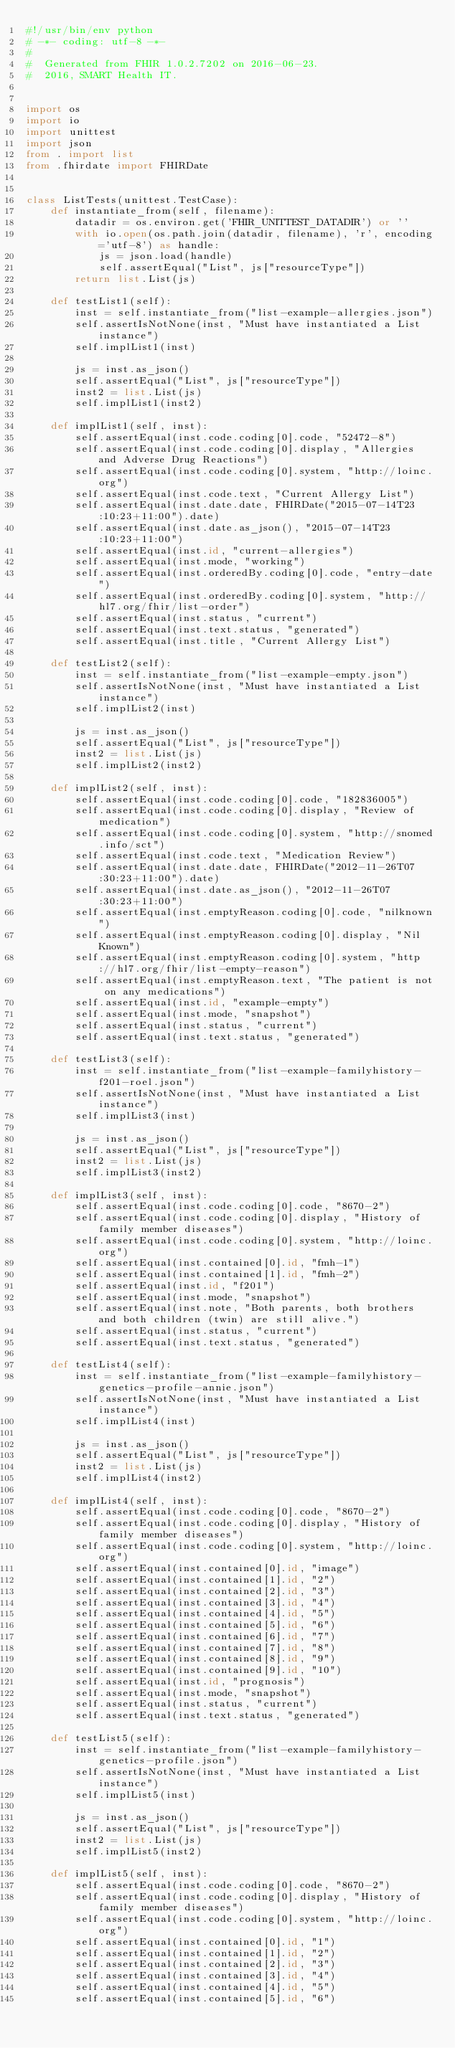<code> <loc_0><loc_0><loc_500><loc_500><_Python_>#!/usr/bin/env python
# -*- coding: utf-8 -*-
#
#  Generated from FHIR 1.0.2.7202 on 2016-06-23.
#  2016, SMART Health IT.


import os
import io
import unittest
import json
from . import list
from .fhirdate import FHIRDate


class ListTests(unittest.TestCase):
    def instantiate_from(self, filename):
        datadir = os.environ.get('FHIR_UNITTEST_DATADIR') or ''
        with io.open(os.path.join(datadir, filename), 'r', encoding='utf-8') as handle:
            js = json.load(handle)
            self.assertEqual("List", js["resourceType"])
        return list.List(js)
    
    def testList1(self):
        inst = self.instantiate_from("list-example-allergies.json")
        self.assertIsNotNone(inst, "Must have instantiated a List instance")
        self.implList1(inst)
        
        js = inst.as_json()
        self.assertEqual("List", js["resourceType"])
        inst2 = list.List(js)
        self.implList1(inst2)
    
    def implList1(self, inst):
        self.assertEqual(inst.code.coding[0].code, "52472-8")
        self.assertEqual(inst.code.coding[0].display, "Allergies and Adverse Drug Reactions")
        self.assertEqual(inst.code.coding[0].system, "http://loinc.org")
        self.assertEqual(inst.code.text, "Current Allergy List")
        self.assertEqual(inst.date.date, FHIRDate("2015-07-14T23:10:23+11:00").date)
        self.assertEqual(inst.date.as_json(), "2015-07-14T23:10:23+11:00")
        self.assertEqual(inst.id, "current-allergies")
        self.assertEqual(inst.mode, "working")
        self.assertEqual(inst.orderedBy.coding[0].code, "entry-date")
        self.assertEqual(inst.orderedBy.coding[0].system, "http://hl7.org/fhir/list-order")
        self.assertEqual(inst.status, "current")
        self.assertEqual(inst.text.status, "generated")
        self.assertEqual(inst.title, "Current Allergy List")
    
    def testList2(self):
        inst = self.instantiate_from("list-example-empty.json")
        self.assertIsNotNone(inst, "Must have instantiated a List instance")
        self.implList2(inst)
        
        js = inst.as_json()
        self.assertEqual("List", js["resourceType"])
        inst2 = list.List(js)
        self.implList2(inst2)
    
    def implList2(self, inst):
        self.assertEqual(inst.code.coding[0].code, "182836005")
        self.assertEqual(inst.code.coding[0].display, "Review of medication")
        self.assertEqual(inst.code.coding[0].system, "http://snomed.info/sct")
        self.assertEqual(inst.code.text, "Medication Review")
        self.assertEqual(inst.date.date, FHIRDate("2012-11-26T07:30:23+11:00").date)
        self.assertEqual(inst.date.as_json(), "2012-11-26T07:30:23+11:00")
        self.assertEqual(inst.emptyReason.coding[0].code, "nilknown")
        self.assertEqual(inst.emptyReason.coding[0].display, "Nil Known")
        self.assertEqual(inst.emptyReason.coding[0].system, "http://hl7.org/fhir/list-empty-reason")
        self.assertEqual(inst.emptyReason.text, "The patient is not on any medications")
        self.assertEqual(inst.id, "example-empty")
        self.assertEqual(inst.mode, "snapshot")
        self.assertEqual(inst.status, "current")
        self.assertEqual(inst.text.status, "generated")
    
    def testList3(self):
        inst = self.instantiate_from("list-example-familyhistory-f201-roel.json")
        self.assertIsNotNone(inst, "Must have instantiated a List instance")
        self.implList3(inst)
        
        js = inst.as_json()
        self.assertEqual("List", js["resourceType"])
        inst2 = list.List(js)
        self.implList3(inst2)
    
    def implList3(self, inst):
        self.assertEqual(inst.code.coding[0].code, "8670-2")
        self.assertEqual(inst.code.coding[0].display, "History of family member diseases")
        self.assertEqual(inst.code.coding[0].system, "http://loinc.org")
        self.assertEqual(inst.contained[0].id, "fmh-1")
        self.assertEqual(inst.contained[1].id, "fmh-2")
        self.assertEqual(inst.id, "f201")
        self.assertEqual(inst.mode, "snapshot")
        self.assertEqual(inst.note, "Both parents, both brothers and both children (twin) are still alive.")
        self.assertEqual(inst.status, "current")
        self.assertEqual(inst.text.status, "generated")
    
    def testList4(self):
        inst = self.instantiate_from("list-example-familyhistory-genetics-profile-annie.json")
        self.assertIsNotNone(inst, "Must have instantiated a List instance")
        self.implList4(inst)
        
        js = inst.as_json()
        self.assertEqual("List", js["resourceType"])
        inst2 = list.List(js)
        self.implList4(inst2)
    
    def implList4(self, inst):
        self.assertEqual(inst.code.coding[0].code, "8670-2")
        self.assertEqual(inst.code.coding[0].display, "History of family member diseases")
        self.assertEqual(inst.code.coding[0].system, "http://loinc.org")
        self.assertEqual(inst.contained[0].id, "image")
        self.assertEqual(inst.contained[1].id, "2")
        self.assertEqual(inst.contained[2].id, "3")
        self.assertEqual(inst.contained[3].id, "4")
        self.assertEqual(inst.contained[4].id, "5")
        self.assertEqual(inst.contained[5].id, "6")
        self.assertEqual(inst.contained[6].id, "7")
        self.assertEqual(inst.contained[7].id, "8")
        self.assertEqual(inst.contained[8].id, "9")
        self.assertEqual(inst.contained[9].id, "10")
        self.assertEqual(inst.id, "prognosis")
        self.assertEqual(inst.mode, "snapshot")
        self.assertEqual(inst.status, "current")
        self.assertEqual(inst.text.status, "generated")
    
    def testList5(self):
        inst = self.instantiate_from("list-example-familyhistory-genetics-profile.json")
        self.assertIsNotNone(inst, "Must have instantiated a List instance")
        self.implList5(inst)
        
        js = inst.as_json()
        self.assertEqual("List", js["resourceType"])
        inst2 = list.List(js)
        self.implList5(inst2)
    
    def implList5(self, inst):
        self.assertEqual(inst.code.coding[0].code, "8670-2")
        self.assertEqual(inst.code.coding[0].display, "History of family member diseases")
        self.assertEqual(inst.code.coding[0].system, "http://loinc.org")
        self.assertEqual(inst.contained[0].id, "1")
        self.assertEqual(inst.contained[1].id, "2")
        self.assertEqual(inst.contained[2].id, "3")
        self.assertEqual(inst.contained[3].id, "4")
        self.assertEqual(inst.contained[4].id, "5")
        self.assertEqual(inst.contained[5].id, "6")</code> 